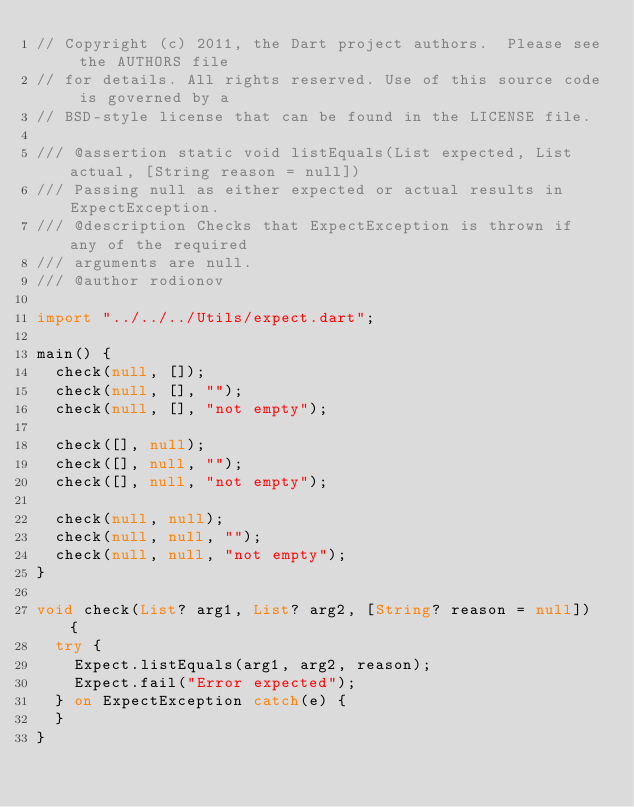<code> <loc_0><loc_0><loc_500><loc_500><_Dart_>// Copyright (c) 2011, the Dart project authors.  Please see the AUTHORS file
// for details. All rights reserved. Use of this source code is governed by a
// BSD-style license that can be found in the LICENSE file.

/// @assertion static void listEquals(List expected, List actual, [String reason = null])
/// Passing null as either expected or actual results in ExpectException. 
/// @description Checks that ExpectException is thrown if any of the required
/// arguments are null.
/// @author rodionov

import "../../../Utils/expect.dart";

main() {
  check(null, []);
  check(null, [], "");
  check(null, [], "not empty");

  check([], null);
  check([], null, "");
  check([], null, "not empty");

  check(null, null);
  check(null, null, "");
  check(null, null, "not empty");
}

void check(List? arg1, List? arg2, [String? reason = null]) {
  try {
    Expect.listEquals(arg1, arg2, reason);
    Expect.fail("Error expected");
  } on ExpectException catch(e) {
  }
}
</code> 